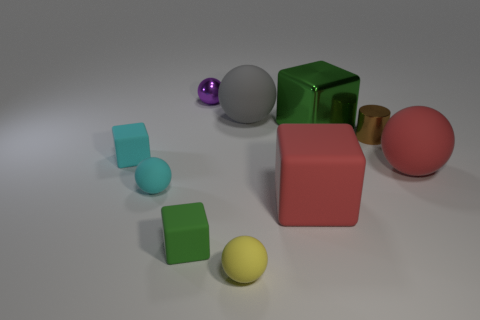What is the size of the green block that is to the right of the tiny purple ball on the left side of the tiny metal cylinder? large 